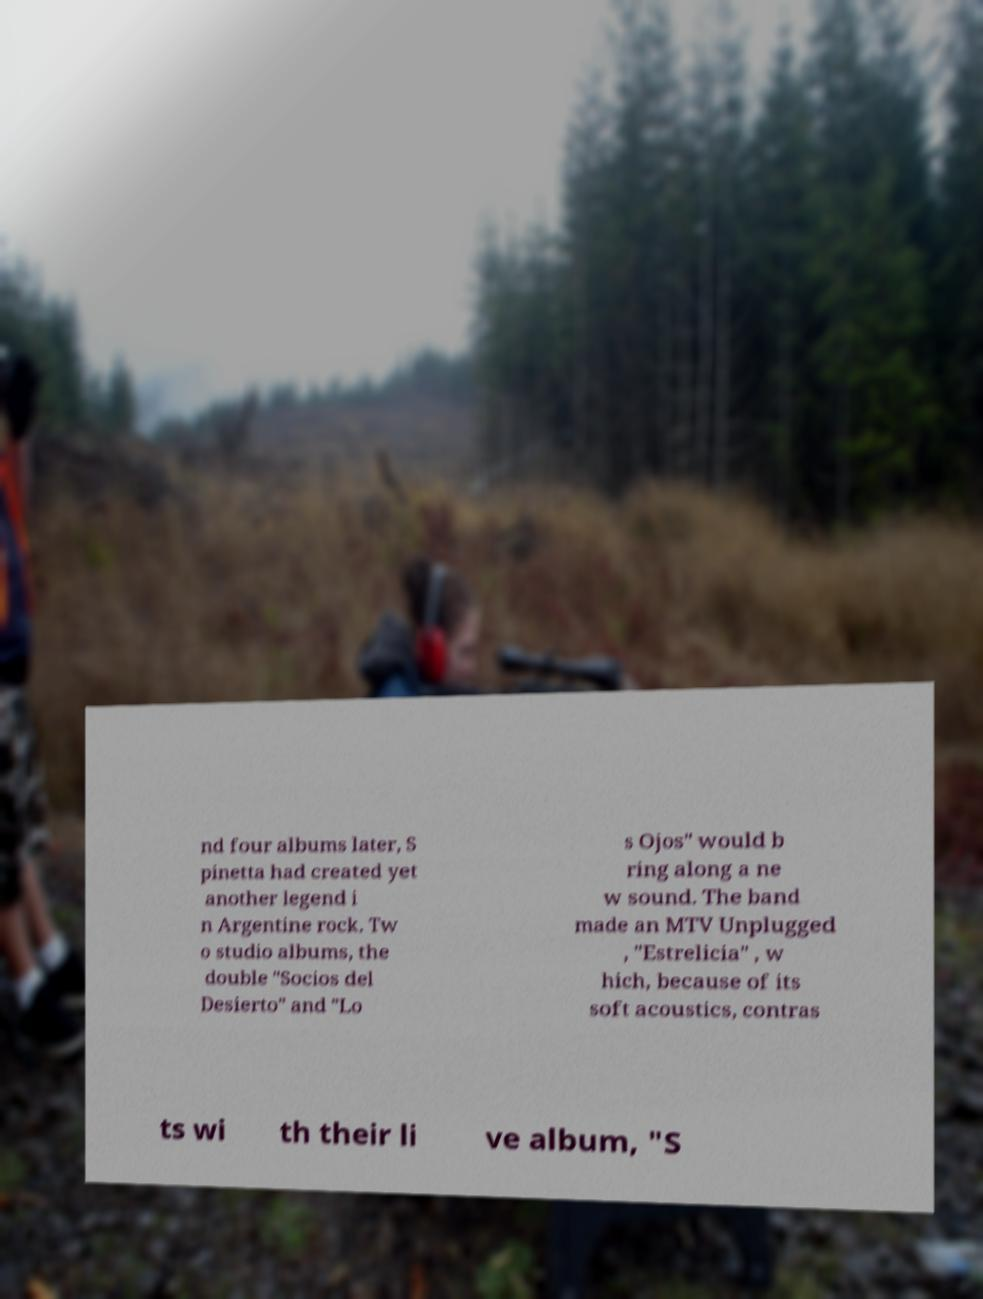Could you extract and type out the text from this image? nd four albums later, S pinetta had created yet another legend i n Argentine rock. Tw o studio albums, the double "Socios del Desierto" and "Lo s Ojos" would b ring along a ne w sound. The band made an MTV Unplugged , "Estrelicia" , w hich, because of its soft acoustics, contras ts wi th their li ve album, "S 